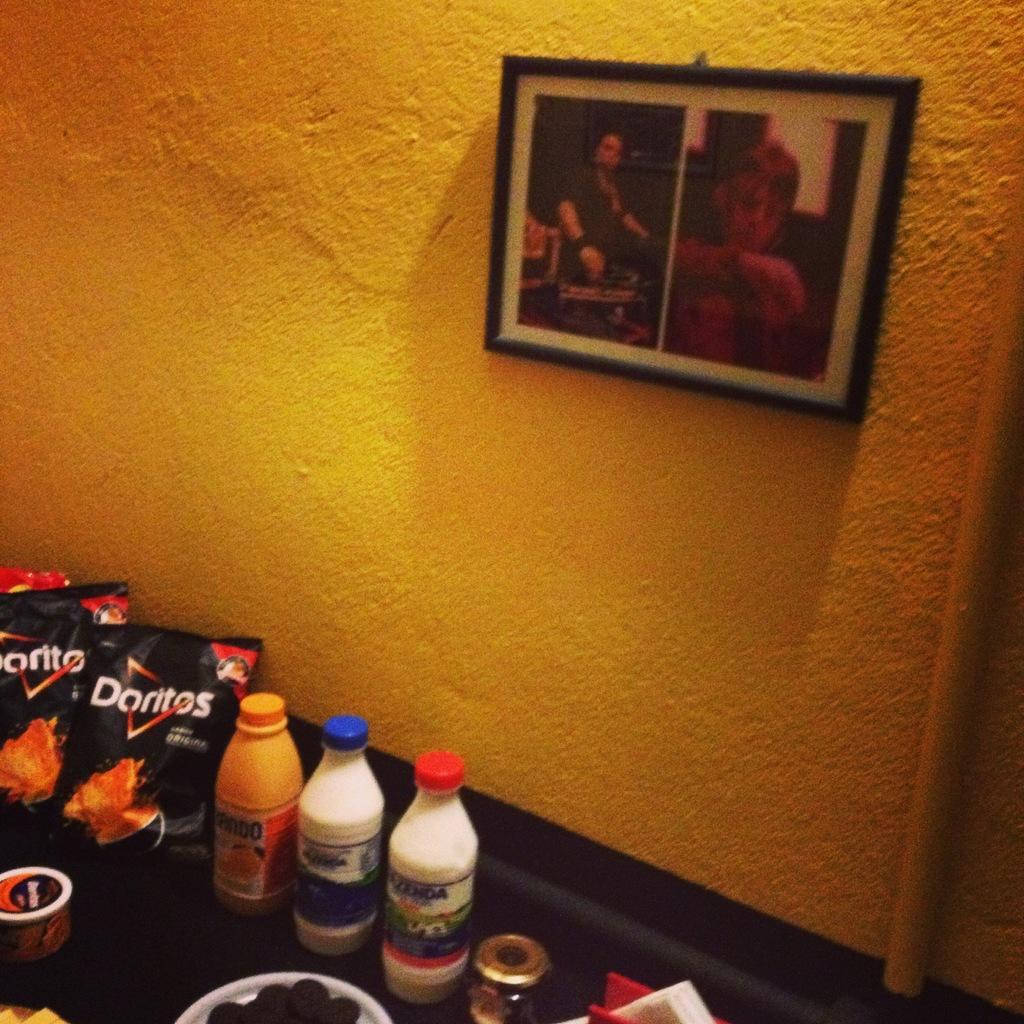Can you describe this image briefly? In this picture we can see a frame on the wall. And these are the bottles and there are some packets. 